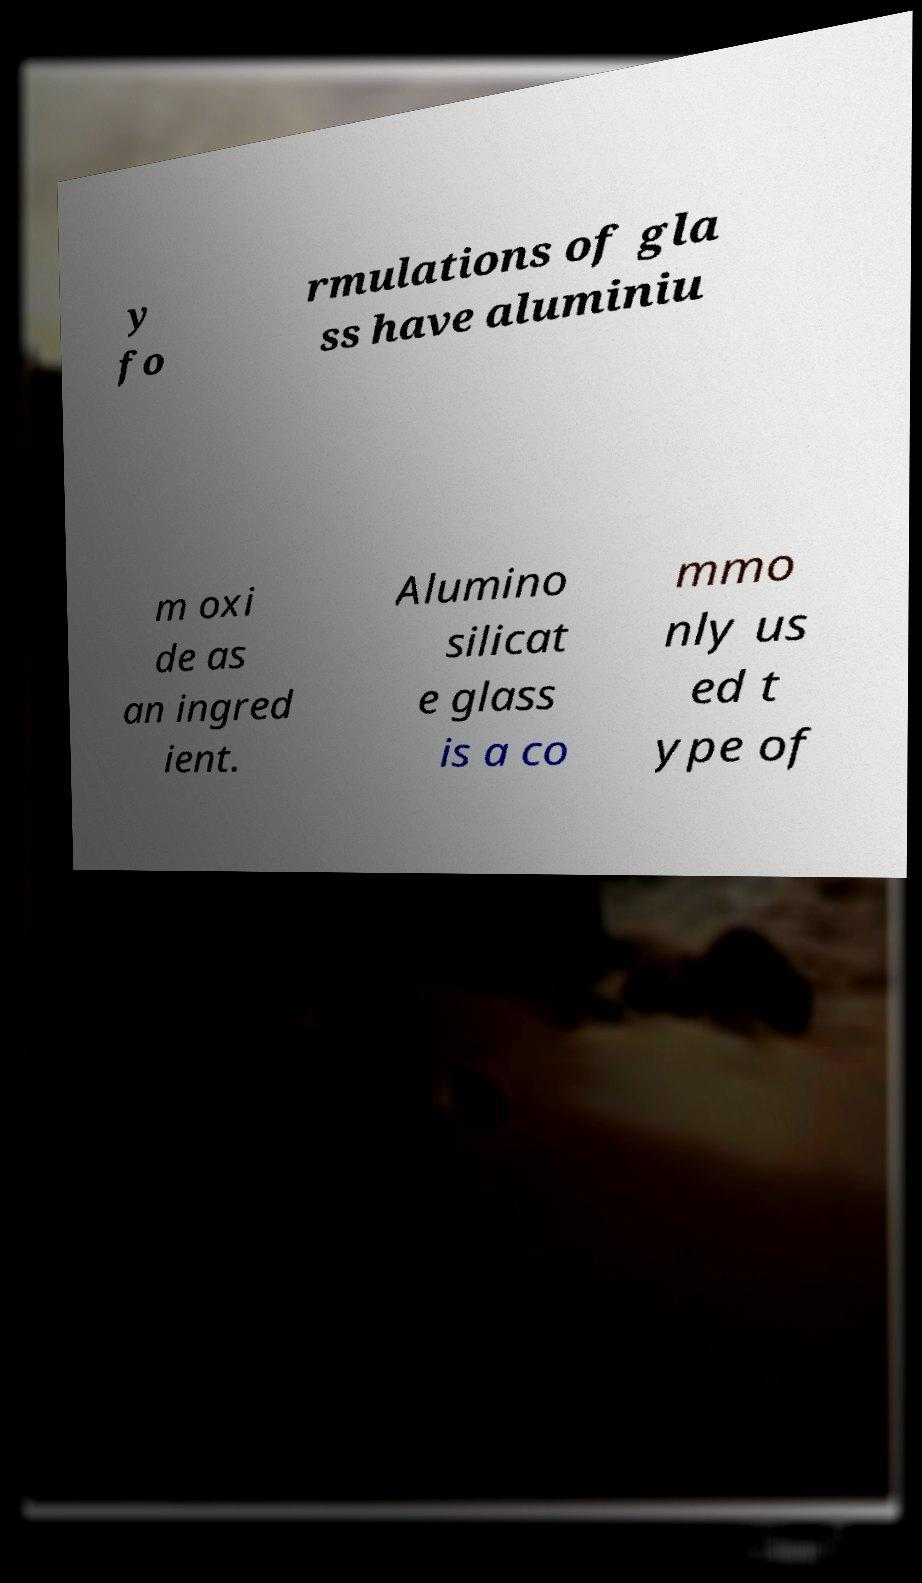Please read and relay the text visible in this image. What does it say? y fo rmulations of gla ss have aluminiu m oxi de as an ingred ient. Alumino silicat e glass is a co mmo nly us ed t ype of 